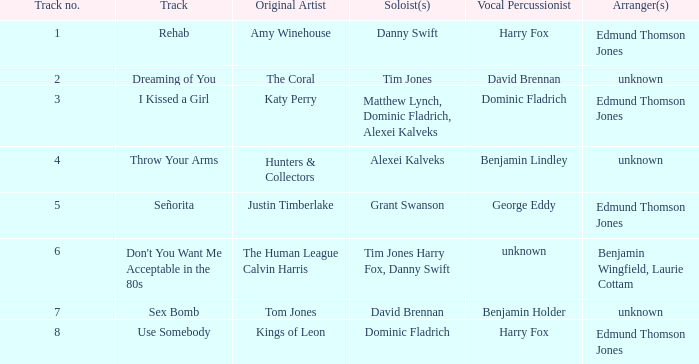Who is the primary artist behind "use somebody"? Kings of Leon. Can you give me this table as a dict? {'header': ['Track no.', 'Track', 'Original Artist', 'Soloist(s)', 'Vocal Percussionist', 'Arranger(s)'], 'rows': [['1', 'Rehab', 'Amy Winehouse', 'Danny Swift', 'Harry Fox', 'Edmund Thomson Jones'], ['2', 'Dreaming of You', 'The Coral', 'Tim Jones', 'David Brennan', 'unknown'], ['3', 'I Kissed a Girl', 'Katy Perry', 'Matthew Lynch, Dominic Fladrich, Alexei Kalveks', 'Dominic Fladrich', 'Edmund Thomson Jones'], ['4', 'Throw Your Arms', 'Hunters & Collectors', 'Alexei Kalveks', 'Benjamin Lindley', 'unknown'], ['5', 'Señorita', 'Justin Timberlake', 'Grant Swanson', 'George Eddy', 'Edmund Thomson Jones'], ['6', "Don't You Want Me Acceptable in the 80s", 'The Human League Calvin Harris', 'Tim Jones Harry Fox, Danny Swift', 'unknown', 'Benjamin Wingfield, Laurie Cottam'], ['7', 'Sex Bomb', 'Tom Jones', 'David Brennan', 'Benjamin Holder', 'unknown'], ['8', 'Use Somebody', 'Kings of Leon', 'Dominic Fladrich', 'Harry Fox', 'Edmund Thomson Jones']]} 